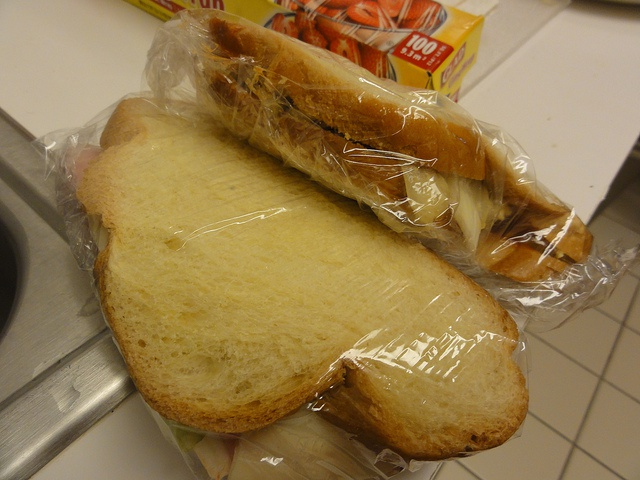Describe the objects in this image and their specific colors. I can see sandwich in darkgray, tan, olive, and maroon tones, sandwich in darkgray, olive, maroon, and tan tones, and sink in darkgray and gray tones in this image. 